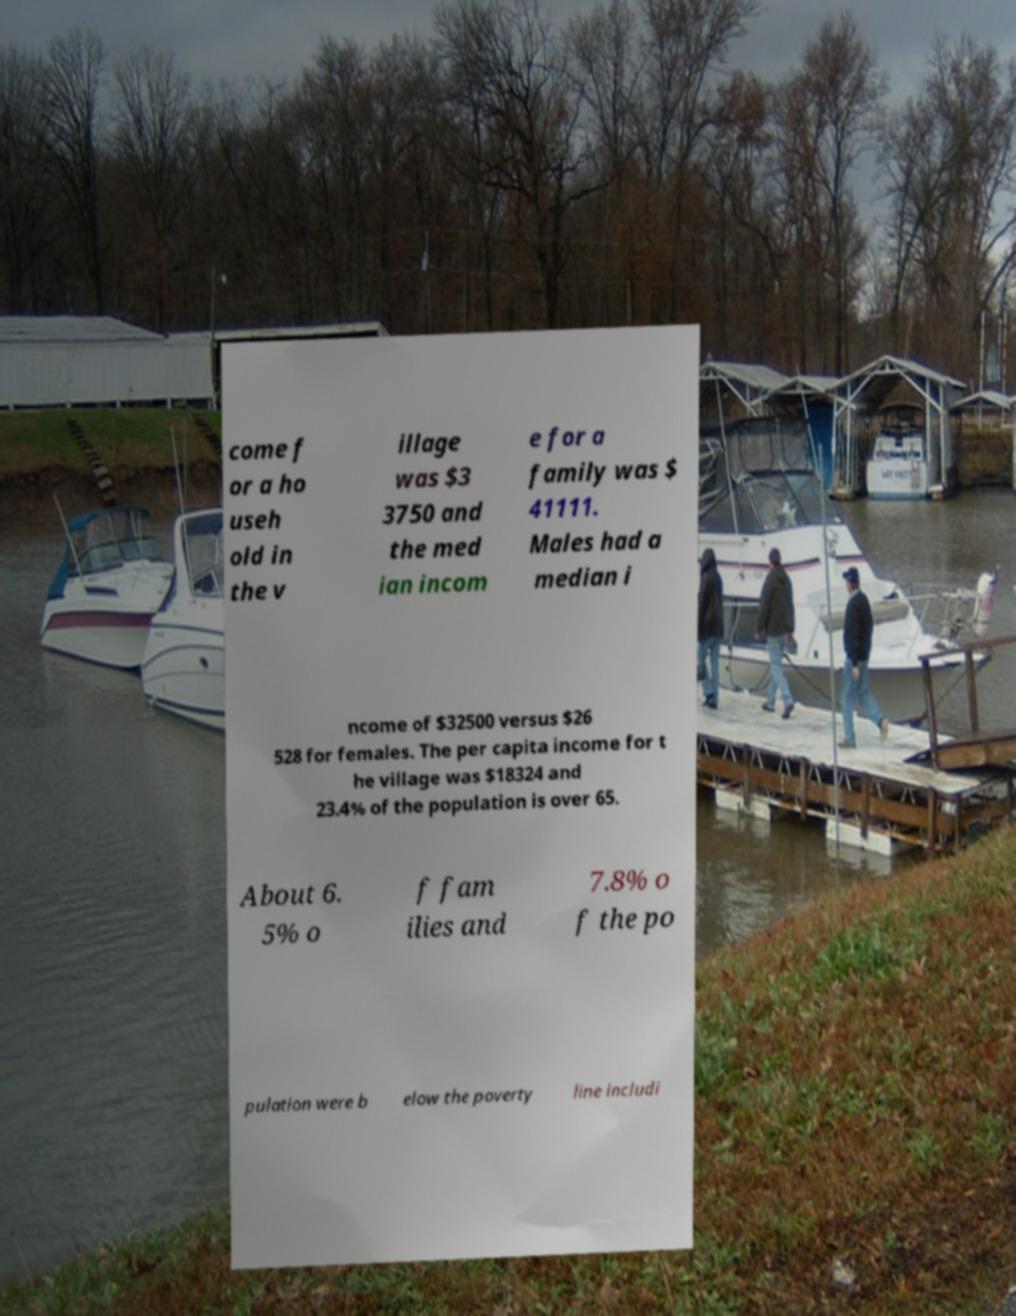I need the written content from this picture converted into text. Can you do that? come f or a ho useh old in the v illage was $3 3750 and the med ian incom e for a family was $ 41111. Males had a median i ncome of $32500 versus $26 528 for females. The per capita income for t he village was $18324 and 23.4% of the population is over 65. About 6. 5% o f fam ilies and 7.8% o f the po pulation were b elow the poverty line includi 